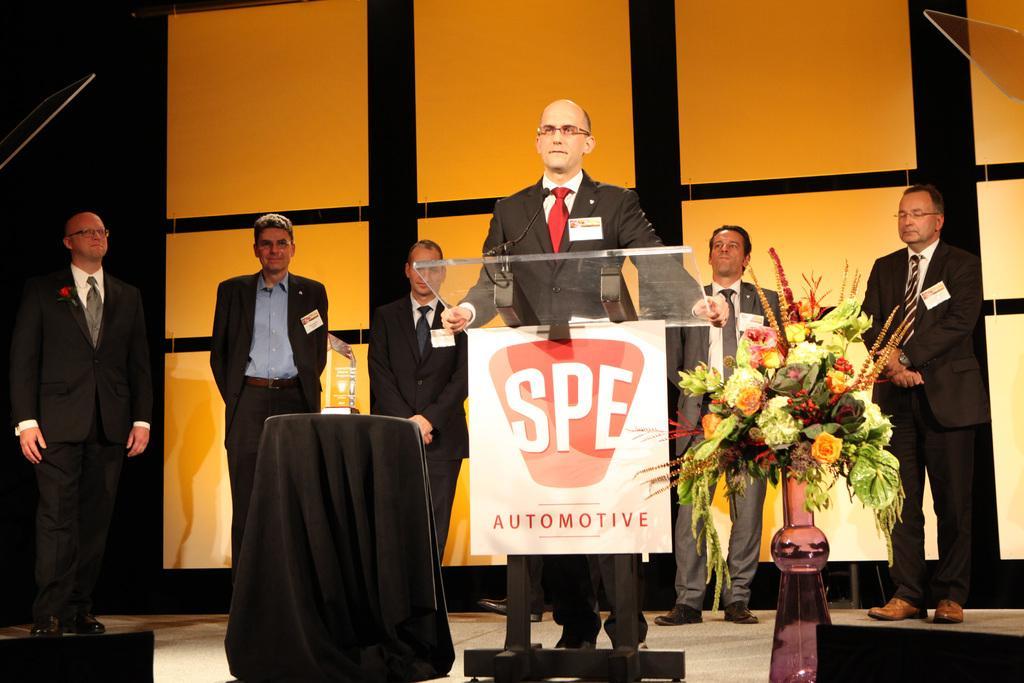Could you give a brief overview of what you see in this image? In the middle of the image, there is a person in a suit, holding glass which is attached to a stand. On the right side, there is a flower vase arranged. On the left side, there is an object on the stool which is covered with a cloth. In the background, there are persons standing and there are white color boards arranged. And background is dark in color. 